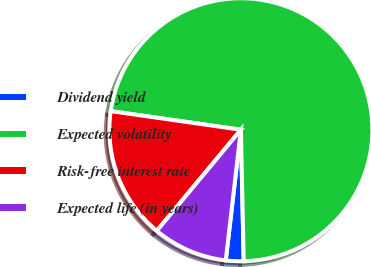Convert chart. <chart><loc_0><loc_0><loc_500><loc_500><pie_chart><fcel>Dividend yield<fcel>Expected volatility<fcel>Risk-free interest rate<fcel>Expected life (in years)<nl><fcel>2.18%<fcel>72.39%<fcel>16.22%<fcel>9.2%<nl></chart> 